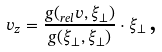<formula> <loc_0><loc_0><loc_500><loc_500>v _ { z } = \frac { g ( _ { r e l } v , \xi _ { \perp } ) } { g ( \xi _ { \perp } , \xi _ { \perp } ) } \cdot \xi _ { \perp } \, \text {,}</formula> 